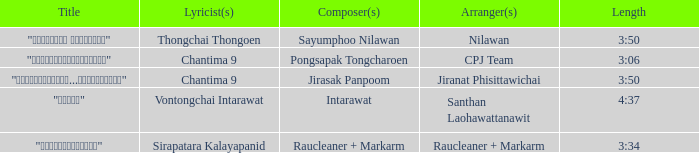Who was the arranger of "ขอโทษ"? Santhan Laohawattanawit. 